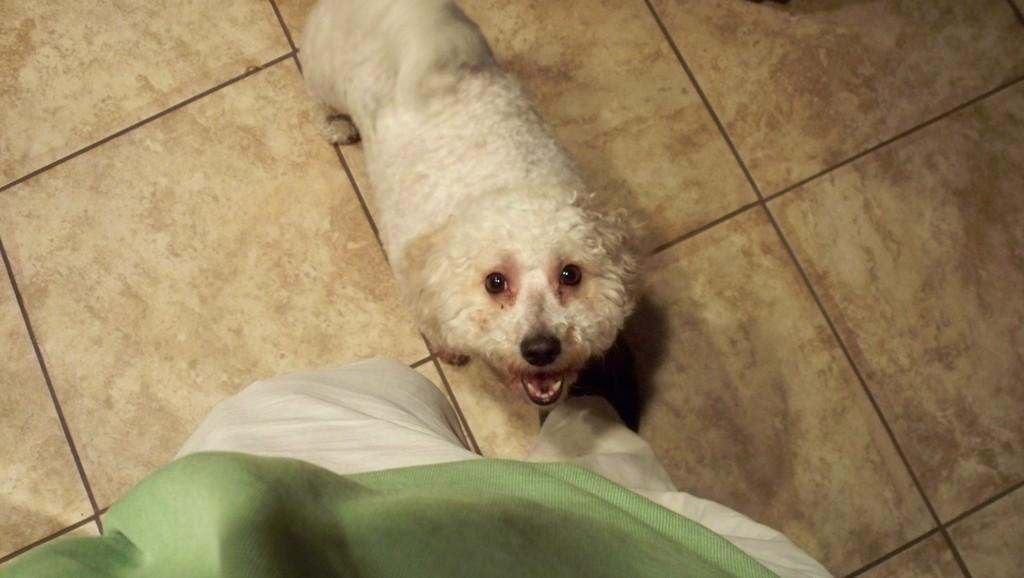Who or what is present in the image? There is a person and a dog in the image. Can you describe the dog in the image? The dog is white in color. What type of error can be seen in the image? There is no error present in the image; it features a person and a white dog. What emotion is the person in the image displaying? The facts provided do not mention the person's emotions, so it cannot be determined from the image. 